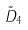<formula> <loc_0><loc_0><loc_500><loc_500>\tilde { D } _ { 4 }</formula> 